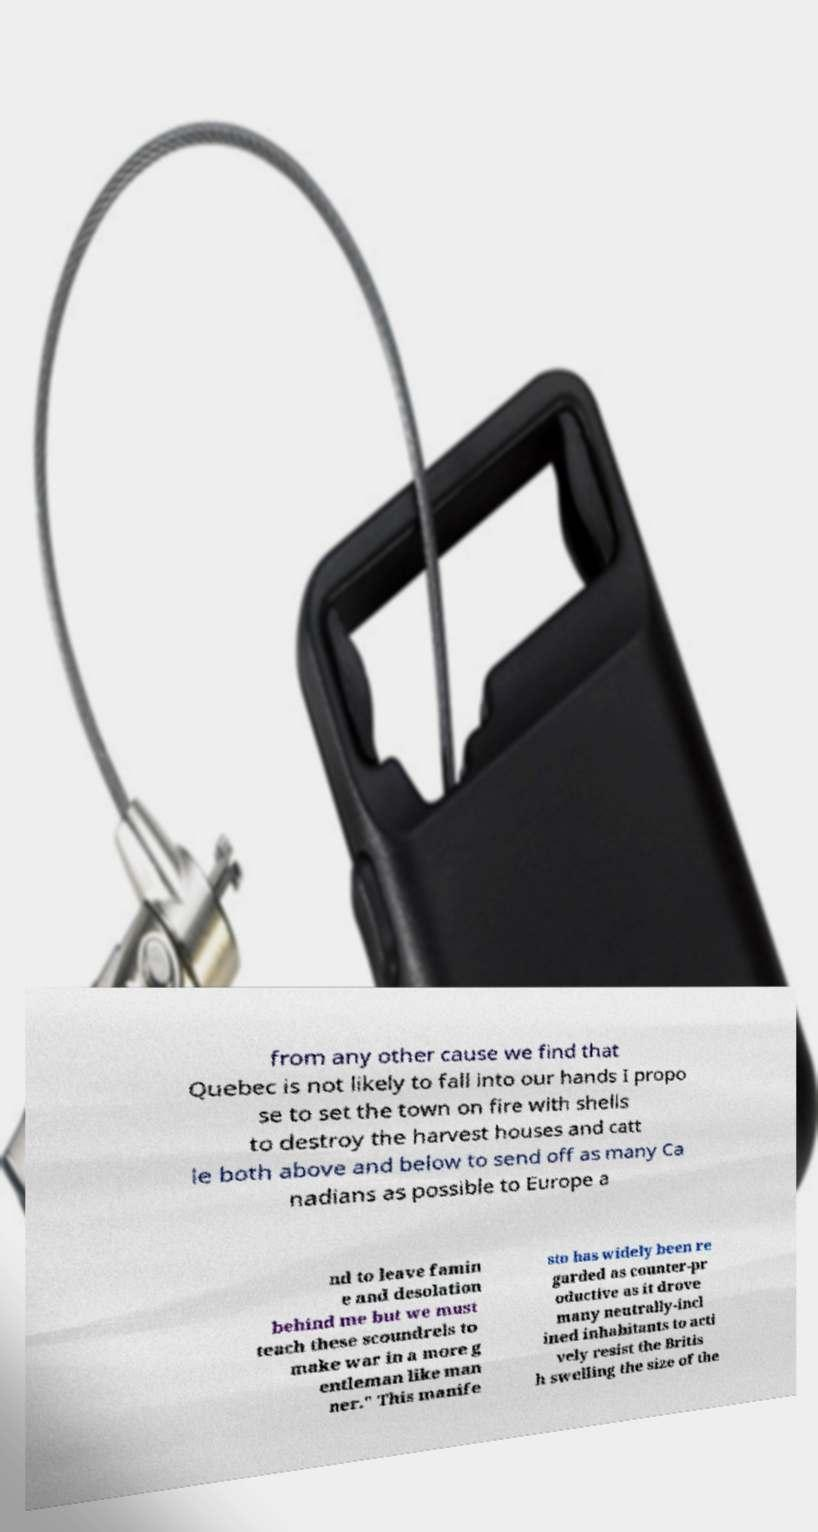Can you accurately transcribe the text from the provided image for me? from any other cause we find that Quebec is not likely to fall into our hands I propo se to set the town on fire with shells to destroy the harvest houses and catt le both above and below to send off as many Ca nadians as possible to Europe a nd to leave famin e and desolation behind me but we must teach these scoundrels to make war in a more g entleman like man ner." This manife sto has widely been re garded as counter-pr oductive as it drove many neutrally-incl ined inhabitants to acti vely resist the Britis h swelling the size of the 